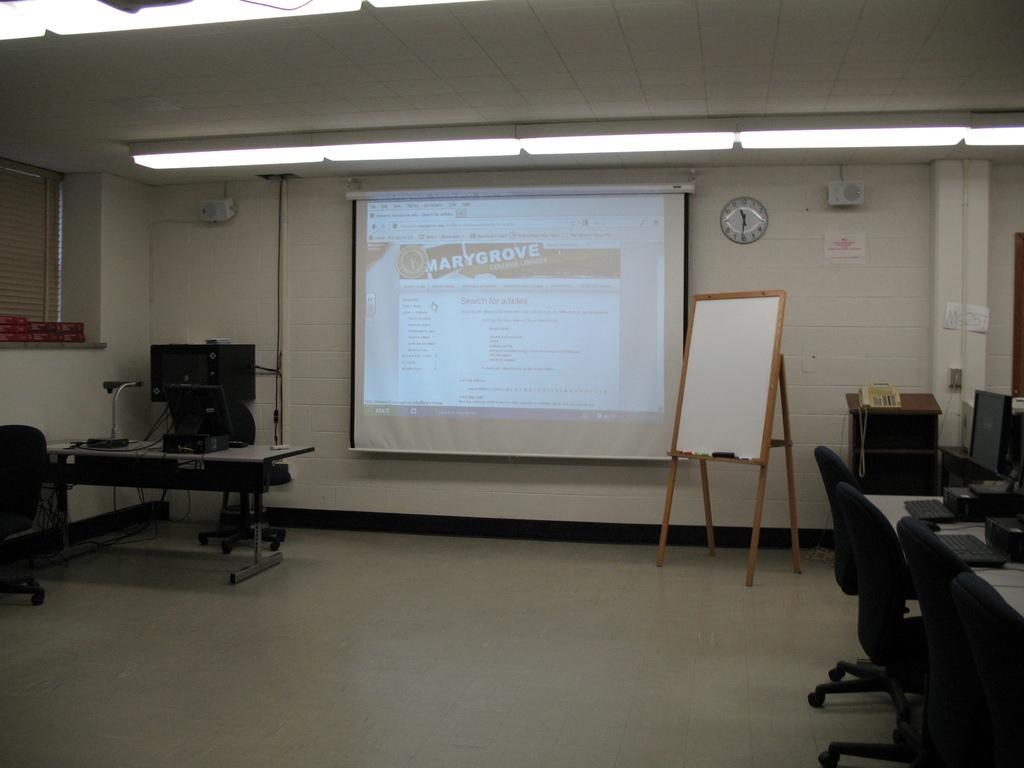What type of furniture can be seen in the image? There are chairs in the image. What is the large, flat surface in the image used for? There is a white color board in the image, which is likely used for writing or displaying information. What is in the background of the image? There is a projector screen and a clock attached to the wall in the background of the image. What color is the wall in the image? The wall is in white color. What type of oatmeal is being served on the white color board in the image? There is no oatmeal present in the image; the white color board is used for writing or displaying information. What color is the orange in the image? There is no orange present in the image. 